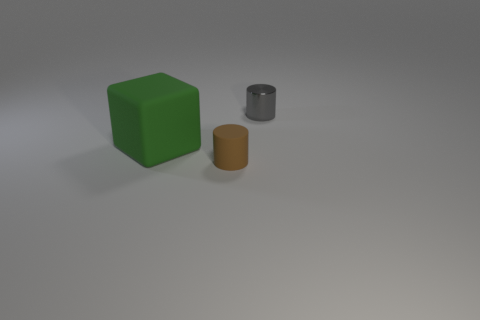Are there any other things that have the same material as the small gray cylinder?
Make the answer very short. No. The rubber object that is the same shape as the small metallic thing is what size?
Your response must be concise. Small. Is the number of tiny gray metallic objects in front of the green block greater than the number of big green things?
Ensure brevity in your answer.  No. Is the thing that is left of the small brown cylinder made of the same material as the small gray cylinder?
Your response must be concise. No. There is a cylinder in front of the gray cylinder that is to the right of the tiny thing in front of the tiny shiny cylinder; how big is it?
Make the answer very short. Small. There is a brown cylinder that is made of the same material as the green thing; what size is it?
Keep it short and to the point. Small. There is a thing that is both behind the brown matte thing and to the left of the gray metallic thing; what is its color?
Make the answer very short. Green. There is a thing in front of the big cube; is it the same shape as the small thing that is behind the large rubber thing?
Make the answer very short. Yes. There is a tiny object that is in front of the large object; what is its material?
Your response must be concise. Rubber. How many things are either rubber objects that are left of the tiny gray shiny cylinder or big objects?
Provide a succinct answer. 2. 